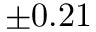<formula> <loc_0><loc_0><loc_500><loc_500>\pm 0 . 2 1</formula> 